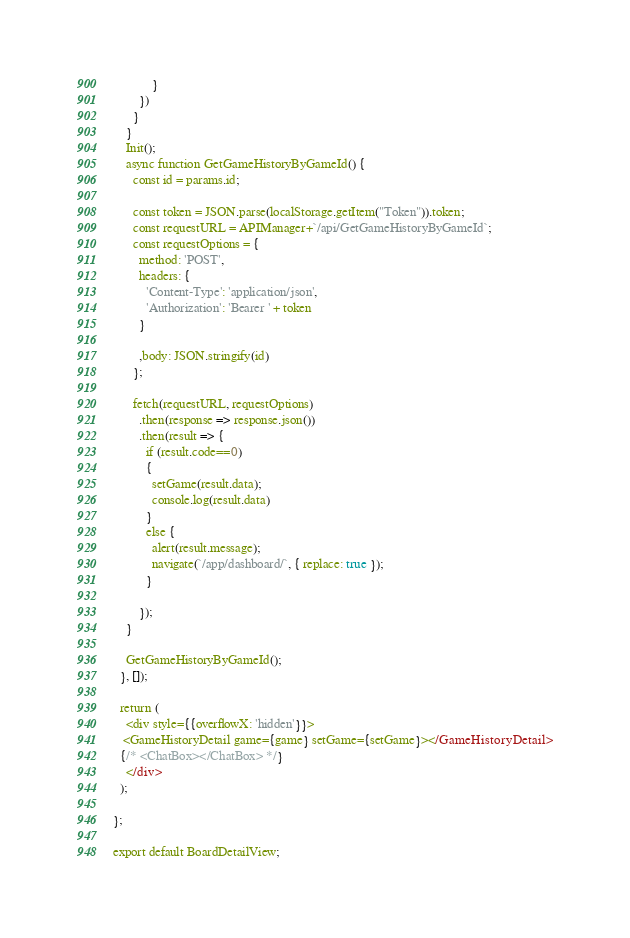Convert code to text. <code><loc_0><loc_0><loc_500><loc_500><_JavaScript_>            }      
        })
      }
    }
    Init();
    async function GetGameHistoryByGameId() {         
      const id = params.id;
     
      const token = JSON.parse(localStorage.getItem("Token")).token;
      const requestURL = APIManager+`/api/GetGameHistoryByGameId`;
      const requestOptions = {
        method: 'POST',
        headers: {
          'Content-Type': 'application/json',
          'Authorization': 'Bearer ' + token
        }

        ,body: JSON.stringify(id)
      };
      
      fetch(requestURL, requestOptions)
        .then(response => response.json())
        .then(result => {
          if (result.code==0)
          {          
            setGame(result.data);
            console.log(result.data)
          }
          else {
            alert(result.message);
            navigate(`/app/dashboard/`, { replace: true });
          } 
           
        });
    }

    GetGameHistoryByGameId();
  }, []);
  
  return (
    <div style={{overflowX: 'hidden'}}>
   <GameHistoryDetail game={game} setGame={setGame}></GameHistoryDetail>
  {/* <ChatBox></ChatBox> */}
    </div>
  );
  
};

export default BoardDetailView;
</code> 